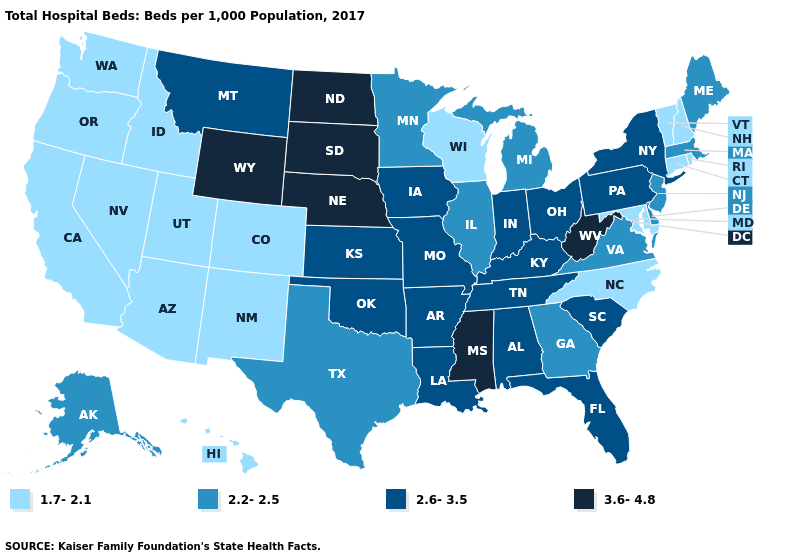What is the value of New Jersey?
Answer briefly. 2.2-2.5. How many symbols are there in the legend?
Concise answer only. 4. Which states have the lowest value in the USA?
Give a very brief answer. Arizona, California, Colorado, Connecticut, Hawaii, Idaho, Maryland, Nevada, New Hampshire, New Mexico, North Carolina, Oregon, Rhode Island, Utah, Vermont, Washington, Wisconsin. Does Massachusetts have the same value as Alaska?
Keep it brief. Yes. What is the value of Rhode Island?
Answer briefly. 1.7-2.1. What is the lowest value in the USA?
Answer briefly. 1.7-2.1. What is the value of Alaska?
Quick response, please. 2.2-2.5. What is the value of Washington?
Short answer required. 1.7-2.1. Name the states that have a value in the range 3.6-4.8?
Concise answer only. Mississippi, Nebraska, North Dakota, South Dakota, West Virginia, Wyoming. Does Massachusetts have the highest value in the USA?
Keep it brief. No. What is the lowest value in states that border Alabama?
Quick response, please. 2.2-2.5. Does Louisiana have the same value as Arkansas?
Quick response, please. Yes. Does Montana have a lower value than North Dakota?
Short answer required. Yes. Name the states that have a value in the range 2.6-3.5?
Short answer required. Alabama, Arkansas, Florida, Indiana, Iowa, Kansas, Kentucky, Louisiana, Missouri, Montana, New York, Ohio, Oklahoma, Pennsylvania, South Carolina, Tennessee. 